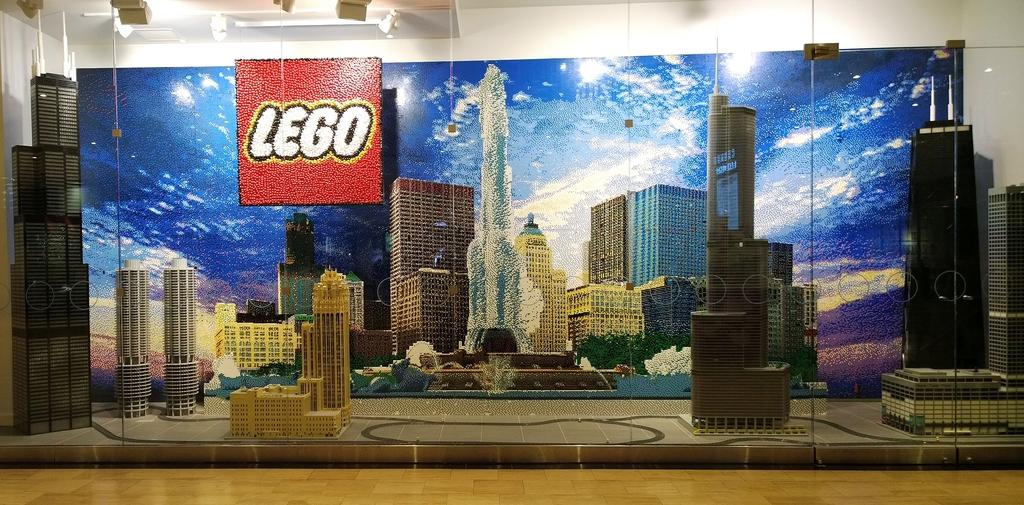What type of crafts can be seen in the image? There are crafts made with legos in the image. What is the surface on which the crafts are displayed? There is a floor at the bottom of the image. What can be seen in the background of the image? There is a wall in the background of the image. What type of pain is the minister experiencing in the image? There is no minister or any indication of pain present in the image. 